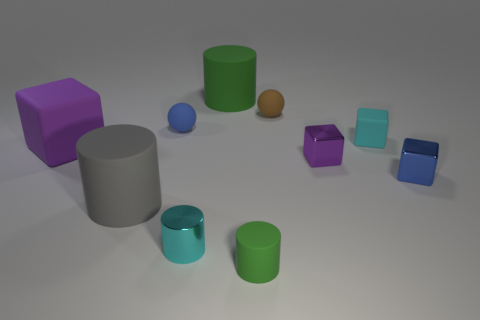Subtract 0 purple balls. How many objects are left? 10 Subtract all blocks. How many objects are left? 6 Subtract all large brown metal objects. Subtract all purple metallic things. How many objects are left? 9 Add 2 blue objects. How many blue objects are left? 4 Add 1 big purple shiny objects. How many big purple shiny objects exist? 1 